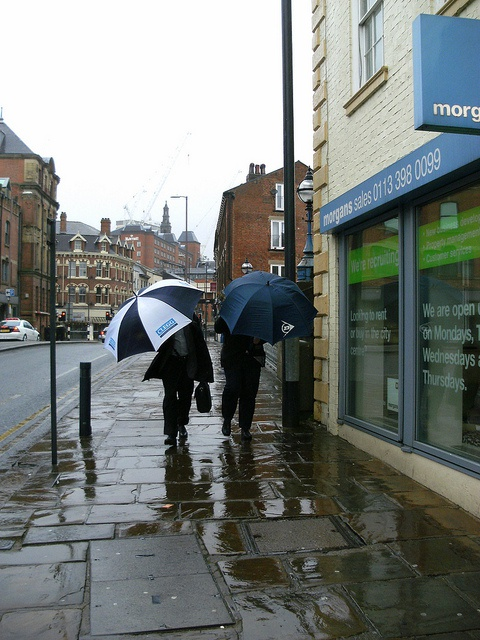Describe the objects in this image and their specific colors. I can see umbrella in white, black, navy, blue, and gray tones, umbrella in white, black, lavender, lightblue, and navy tones, people in white, black, gray, and darkgray tones, people in white, black, gray, darkblue, and blue tones, and car in white, darkgray, lightgray, lightblue, and black tones in this image. 